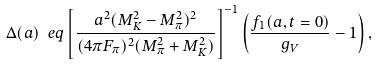Convert formula to latex. <formula><loc_0><loc_0><loc_500><loc_500>\Delta ( a ) \ e q \left [ \frac { a ^ { 2 } ( M _ { K } ^ { 2 } - M _ { \pi } ^ { 2 } ) ^ { 2 } } { ( 4 \pi F _ { \pi } ) ^ { 2 } ( M _ { \pi } ^ { 2 } + M _ { K } ^ { 2 } ) } \right ] ^ { - 1 } \left ( \frac { f _ { 1 } ( a , t = 0 ) } { g _ { V } } - 1 \right ) ,</formula> 